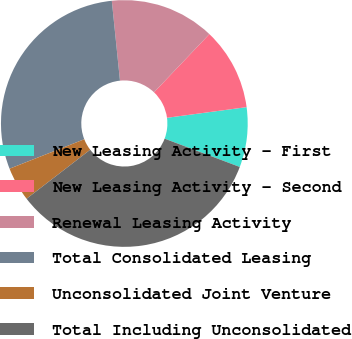<chart> <loc_0><loc_0><loc_500><loc_500><pie_chart><fcel>New Leasing Activity - First<fcel>New Leasing Activity - Second<fcel>Renewal Leasing Activity<fcel>Total Consolidated Leasing<fcel>Unconsolidated Joint Venture<fcel>Total Including Unconsolidated<nl><fcel>7.85%<fcel>10.78%<fcel>13.72%<fcel>29.35%<fcel>4.47%<fcel>33.82%<nl></chart> 